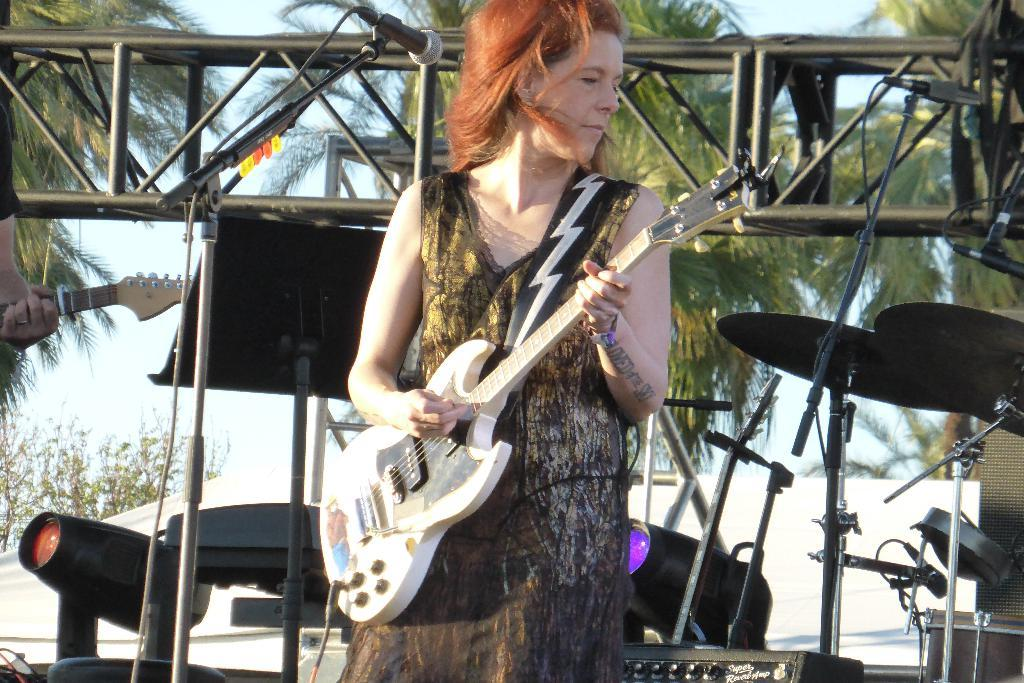What is the woman in the image doing? The woman is playing a guitar in the image. What other objects are related to music in the image? There are musical instruments in the image. What can be seen in the background of the image? There are trees and the sky visible in the background of the image. What type of hand can be seen distributing units in the image? There is no hand or unit distribution present in the image. 